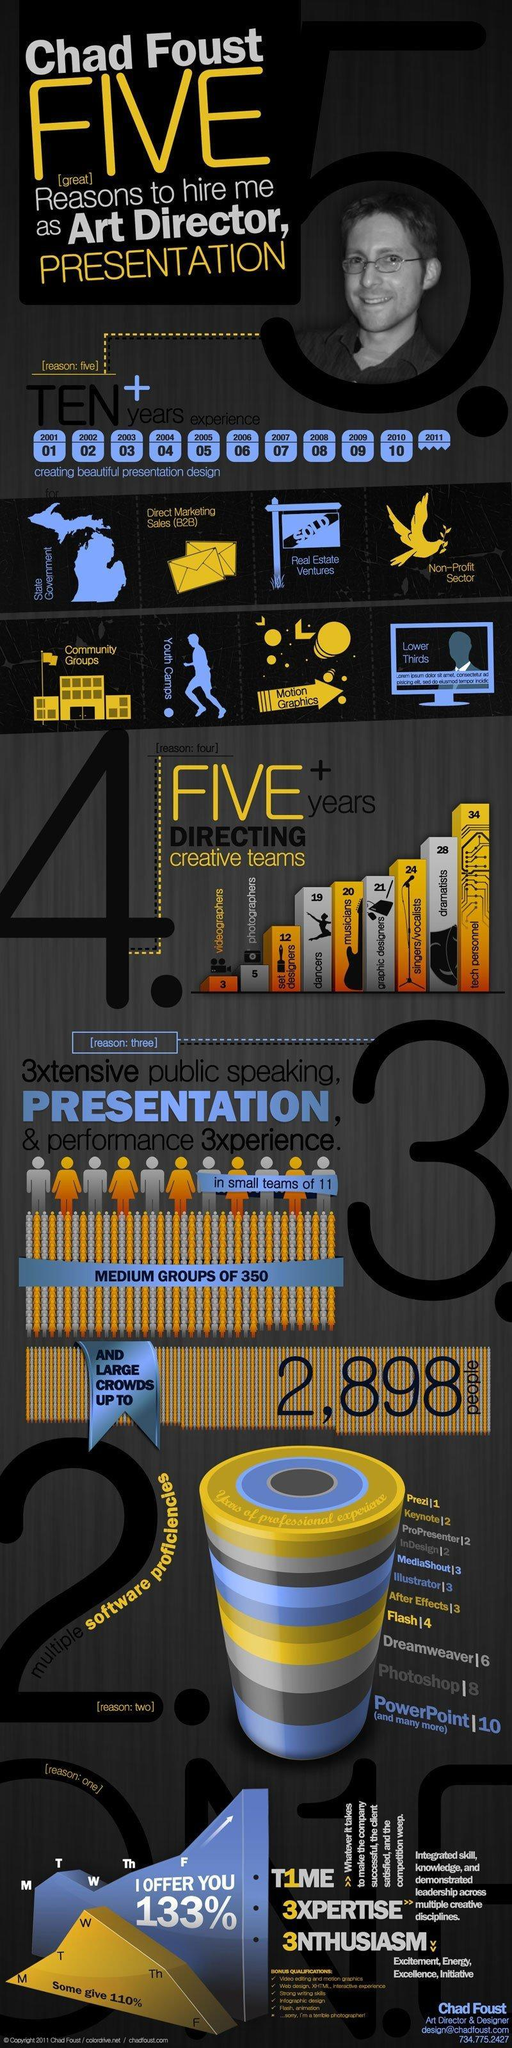Which is the second biggest category of creative teams Chad Foust has directed?
Answer the question with a short phrase. dramatists 